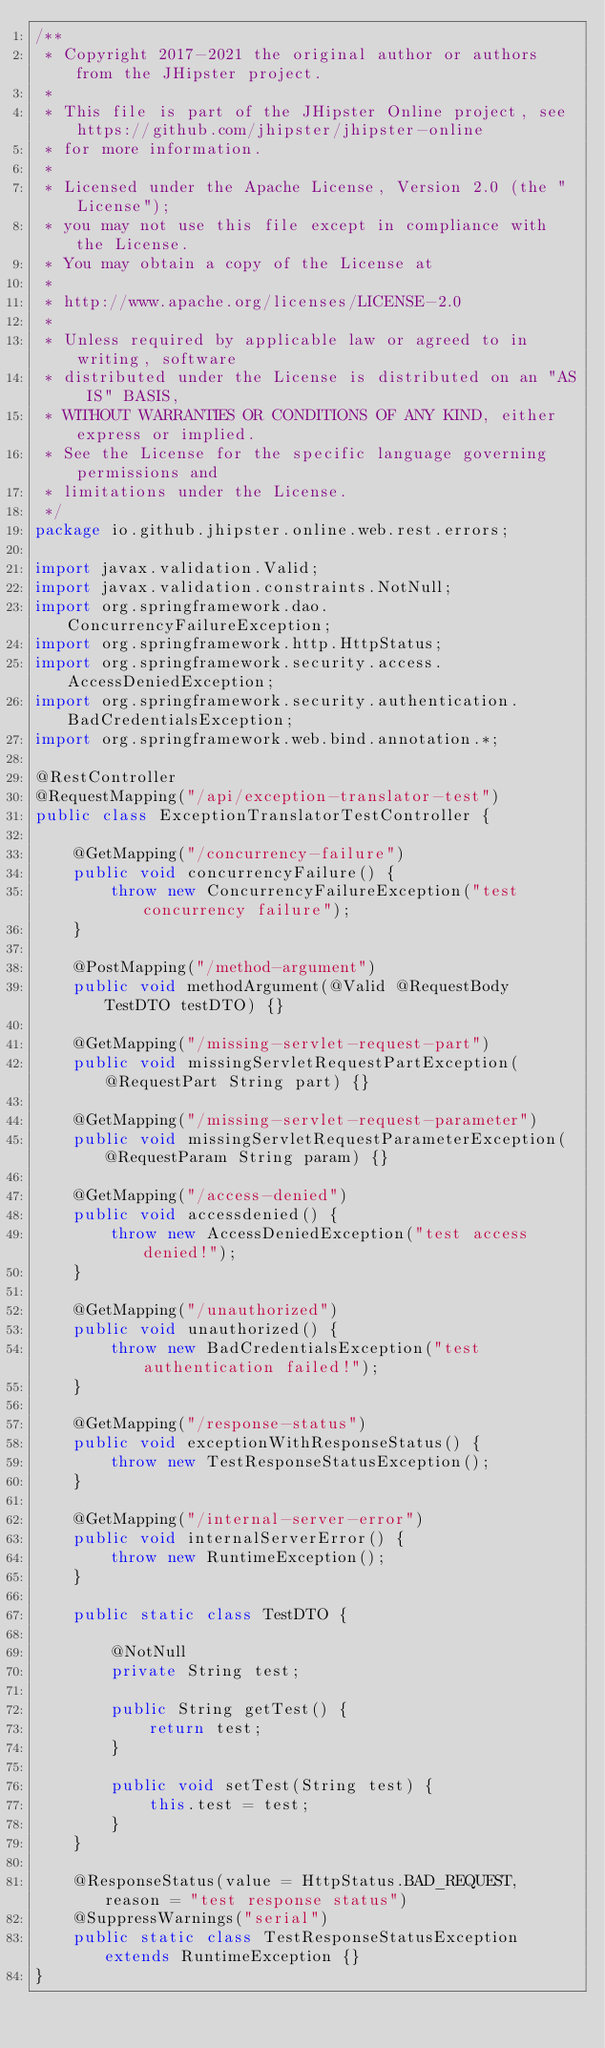Convert code to text. <code><loc_0><loc_0><loc_500><loc_500><_Java_>/**
 * Copyright 2017-2021 the original author or authors from the JHipster project.
 *
 * This file is part of the JHipster Online project, see https://github.com/jhipster/jhipster-online
 * for more information.
 *
 * Licensed under the Apache License, Version 2.0 (the "License");
 * you may not use this file except in compliance with the License.
 * You may obtain a copy of the License at
 *
 * http://www.apache.org/licenses/LICENSE-2.0
 *
 * Unless required by applicable law or agreed to in writing, software
 * distributed under the License is distributed on an "AS IS" BASIS,
 * WITHOUT WARRANTIES OR CONDITIONS OF ANY KIND, either express or implied.
 * See the License for the specific language governing permissions and
 * limitations under the License.
 */
package io.github.jhipster.online.web.rest.errors;

import javax.validation.Valid;
import javax.validation.constraints.NotNull;
import org.springframework.dao.ConcurrencyFailureException;
import org.springframework.http.HttpStatus;
import org.springframework.security.access.AccessDeniedException;
import org.springframework.security.authentication.BadCredentialsException;
import org.springframework.web.bind.annotation.*;

@RestController
@RequestMapping("/api/exception-translator-test")
public class ExceptionTranslatorTestController {

    @GetMapping("/concurrency-failure")
    public void concurrencyFailure() {
        throw new ConcurrencyFailureException("test concurrency failure");
    }

    @PostMapping("/method-argument")
    public void methodArgument(@Valid @RequestBody TestDTO testDTO) {}

    @GetMapping("/missing-servlet-request-part")
    public void missingServletRequestPartException(@RequestPart String part) {}

    @GetMapping("/missing-servlet-request-parameter")
    public void missingServletRequestParameterException(@RequestParam String param) {}

    @GetMapping("/access-denied")
    public void accessdenied() {
        throw new AccessDeniedException("test access denied!");
    }

    @GetMapping("/unauthorized")
    public void unauthorized() {
        throw new BadCredentialsException("test authentication failed!");
    }

    @GetMapping("/response-status")
    public void exceptionWithResponseStatus() {
        throw new TestResponseStatusException();
    }

    @GetMapping("/internal-server-error")
    public void internalServerError() {
        throw new RuntimeException();
    }

    public static class TestDTO {

        @NotNull
        private String test;

        public String getTest() {
            return test;
        }

        public void setTest(String test) {
            this.test = test;
        }
    }

    @ResponseStatus(value = HttpStatus.BAD_REQUEST, reason = "test response status")
    @SuppressWarnings("serial")
    public static class TestResponseStatusException extends RuntimeException {}
}
</code> 